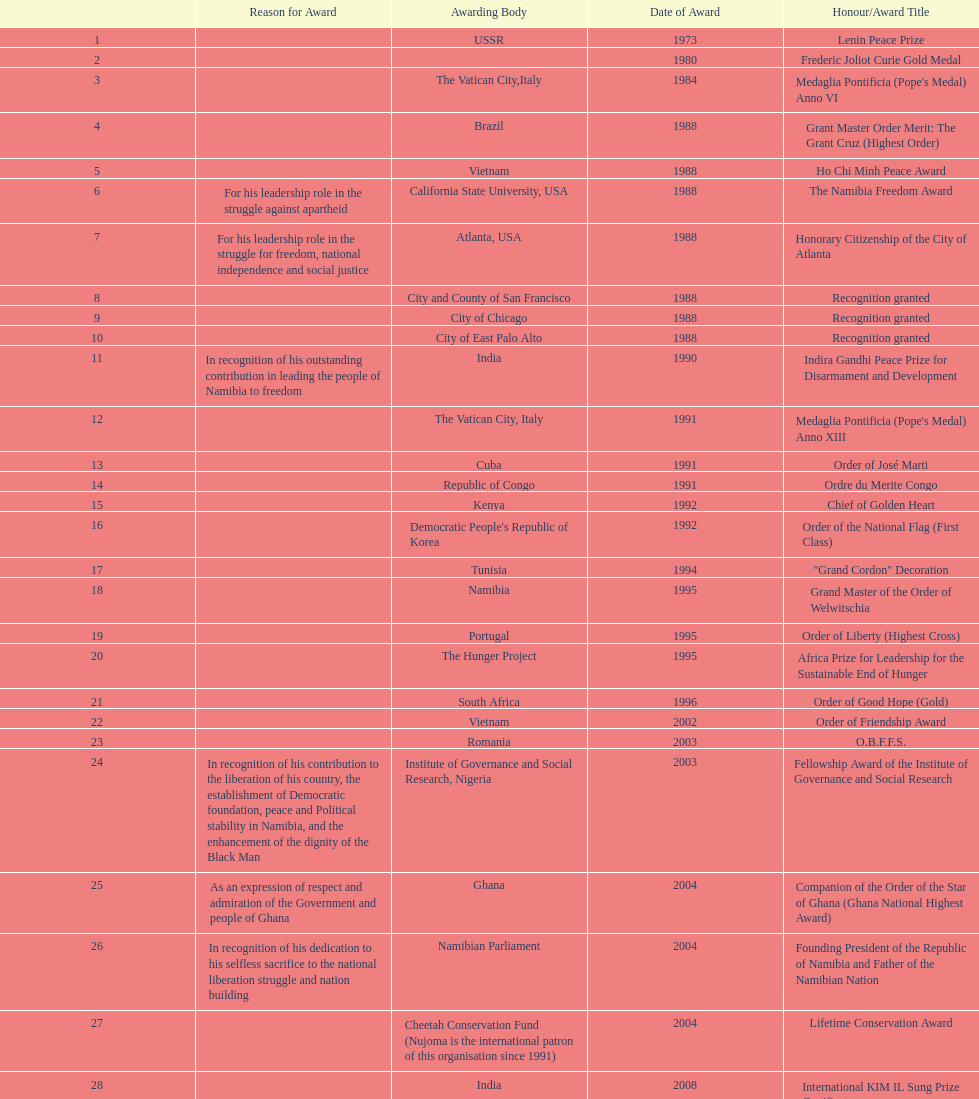What is the most recent award nujoma received? Sir Seretse Khama SADC Meda. 